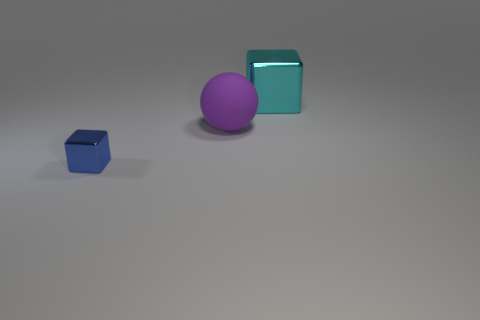Add 2 large metal things. How many objects exist? 5 Subtract all blocks. How many objects are left? 1 Add 1 cyan things. How many cyan things exist? 2 Subtract 0 purple cubes. How many objects are left? 3 Subtract all green cubes. Subtract all brown balls. How many cubes are left? 2 Subtract all cyan metal objects. Subtract all blocks. How many objects are left? 0 Add 3 blue metal objects. How many blue metal objects are left? 4 